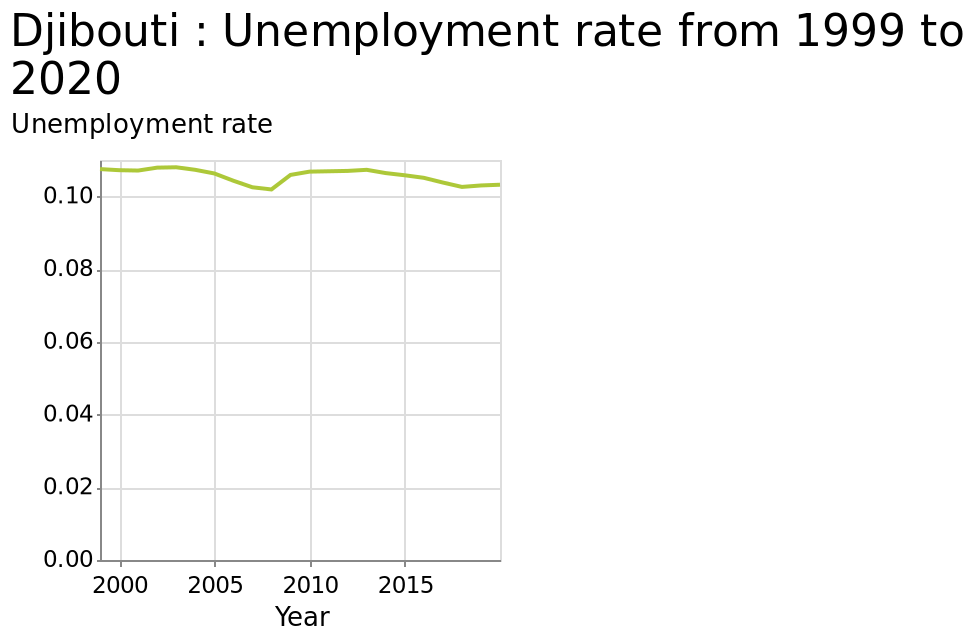<image>
What does the line chart represent for Djibouti? The line chart represents the unemployment rate for Djibouti over the years. please describe the details of the chart Djibouti : Unemployment rate from 1999 to 2020 is a line chart. The y-axis measures Unemployment rate while the x-axis plots Year. Is Djibouti experiencing a constant rise or fall in unemployment rates over the past 15 years? No, Djibouti is not experiencing a constant rise or fall in unemployment rates over the past 15 years. The rates have remained relatively stable. 